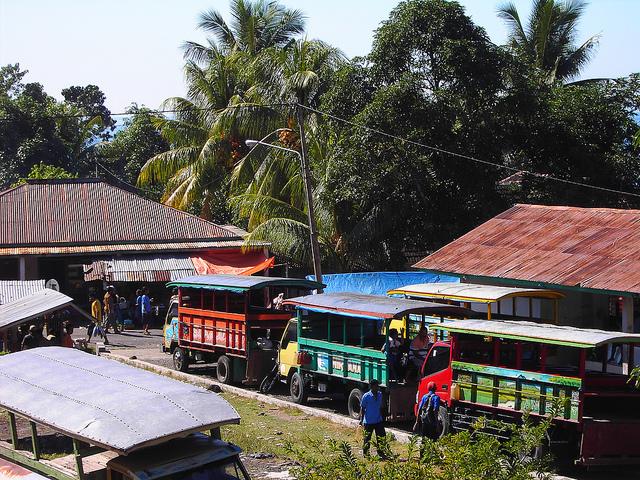Are any of the trucks multicolored?
Give a very brief answer. Yes. Is the sky blue?
Concise answer only. Yes. What color is the first train?
Quick response, please. Red. 